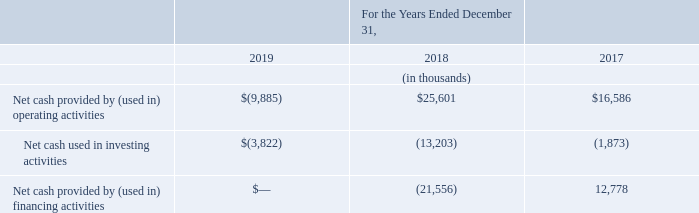Cash flows for the year ended December 31, 2019, 2018 and 2017
Operating Activities: Net cash used in operating activities was $9.9 million for the year ended December 31, 2019 and is comprised of $16.5 million in net loss, $4.5 million change in deferred income taxes and $0.7 million loss from the sale of the investment in JVP offset by $1.0 million in stock based compensation, $2.0 million in depreciation and amortization and $7.1 million, primarily changes in net operating assets and liabilities.
Net cash provided by operating activities was $25.6 million for the year ended December 31, 2018 and is comprised of $20.7 million in net income, $1.6 million in stock-based compensation, $1.8 million in depreciation and amortization, $3.4 million change in warrant liability and a change in deferred income taxes of $2.5 million, offset by a $4.4 million change in net operating assets and liabilities.
Net cash provided by operating activities was $16.6 million for the year ended December 31, 2017 and is comprised of $22.8 million in net income, $0.8 million in stock-based compensation, $0.8 million in depreciation and amortization, $0.6 million change in net operating assets and liabilities, offset by $2.2 million change in the warrant liability and a change in deferred income taxes of $6.2 million.
Investing Activities: During the year ended December 31, 2019, cash used in investing activities of $3.8 million was related to purchases of marketable securities of $24.5 million, purchases of property and equipment of $0.4 million and purchase of additional investment in JVP of $0.7 million offset by redemptions of marketable securities of $18.3 million and $3.5 million from the sale of our interest in JVP.
During the year ended December 31, 2018, cash used in investing activities of $13.2 million was related to purchase of investments of $11.3 million, the purchase of assets under the May 2018 Patent Assignment Agreement of $1.0 million and a $0.9 million investment in the JVP fund.
During the year ended December 31, 2017, cash used in investing activities of $2.0 million was related to the purchase of assets under the first Patent Assignment Agreement, offset by $0.1 million in cash distribution received from our investment in the JVP fund.
Financing Activities: During the year ended December 31, 2019, we did not have any activity related to financing.
During the year ended December 31, 2018, net cash used in financing activities of $21.6 million was primarily from the redemption of Series A-1 Preferred Stock totaling $19.9 million, $2.0 million related to the share repurchase program, offset by $0.3 million of proceeds received from the exercise of stock options.
During the year ended December 31, 2017, net cash provided by financing activities of $12.8 million was primarily from the issuance of Series A-1 Preferred Stock totaling $14.4 million and a Common Share offering for $12.0 million, offset by redeeming and retiring Series A Preferred Stock Financing of $13.8 million.
What is the respective value of purchases relating to the purchase of investments and the purchase of assets under the May 2018 Patent Assignment Agreement? $11.3 million, $1.0 million. What is the respective value of purchases relating to the purchase of marketable securities and purchases of property and equipment? $24.5 million, $0.4 million. What is the respective value of net cash provided by operating activities relating to net income and stock-based compensation? $20.7 million, $1.6 million. What is the percentage change in the net cash provided by operating activities between 2017 and 2018?
Answer scale should be: percent. (25,601 - 16,586)/16,586 
Answer: 54.35. What is the average net cash provided by (used in) financing activities between 2017 and 2018?
Answer scale should be: thousand. (12,778 +(- 21,556))/2 
Answer: -4389. What is the percentage change in net cash used in investing activities between 2018 and 2019?
Answer scale should be: percent. (3,822 - 13,203)/13,203 
Answer: -71.05. 